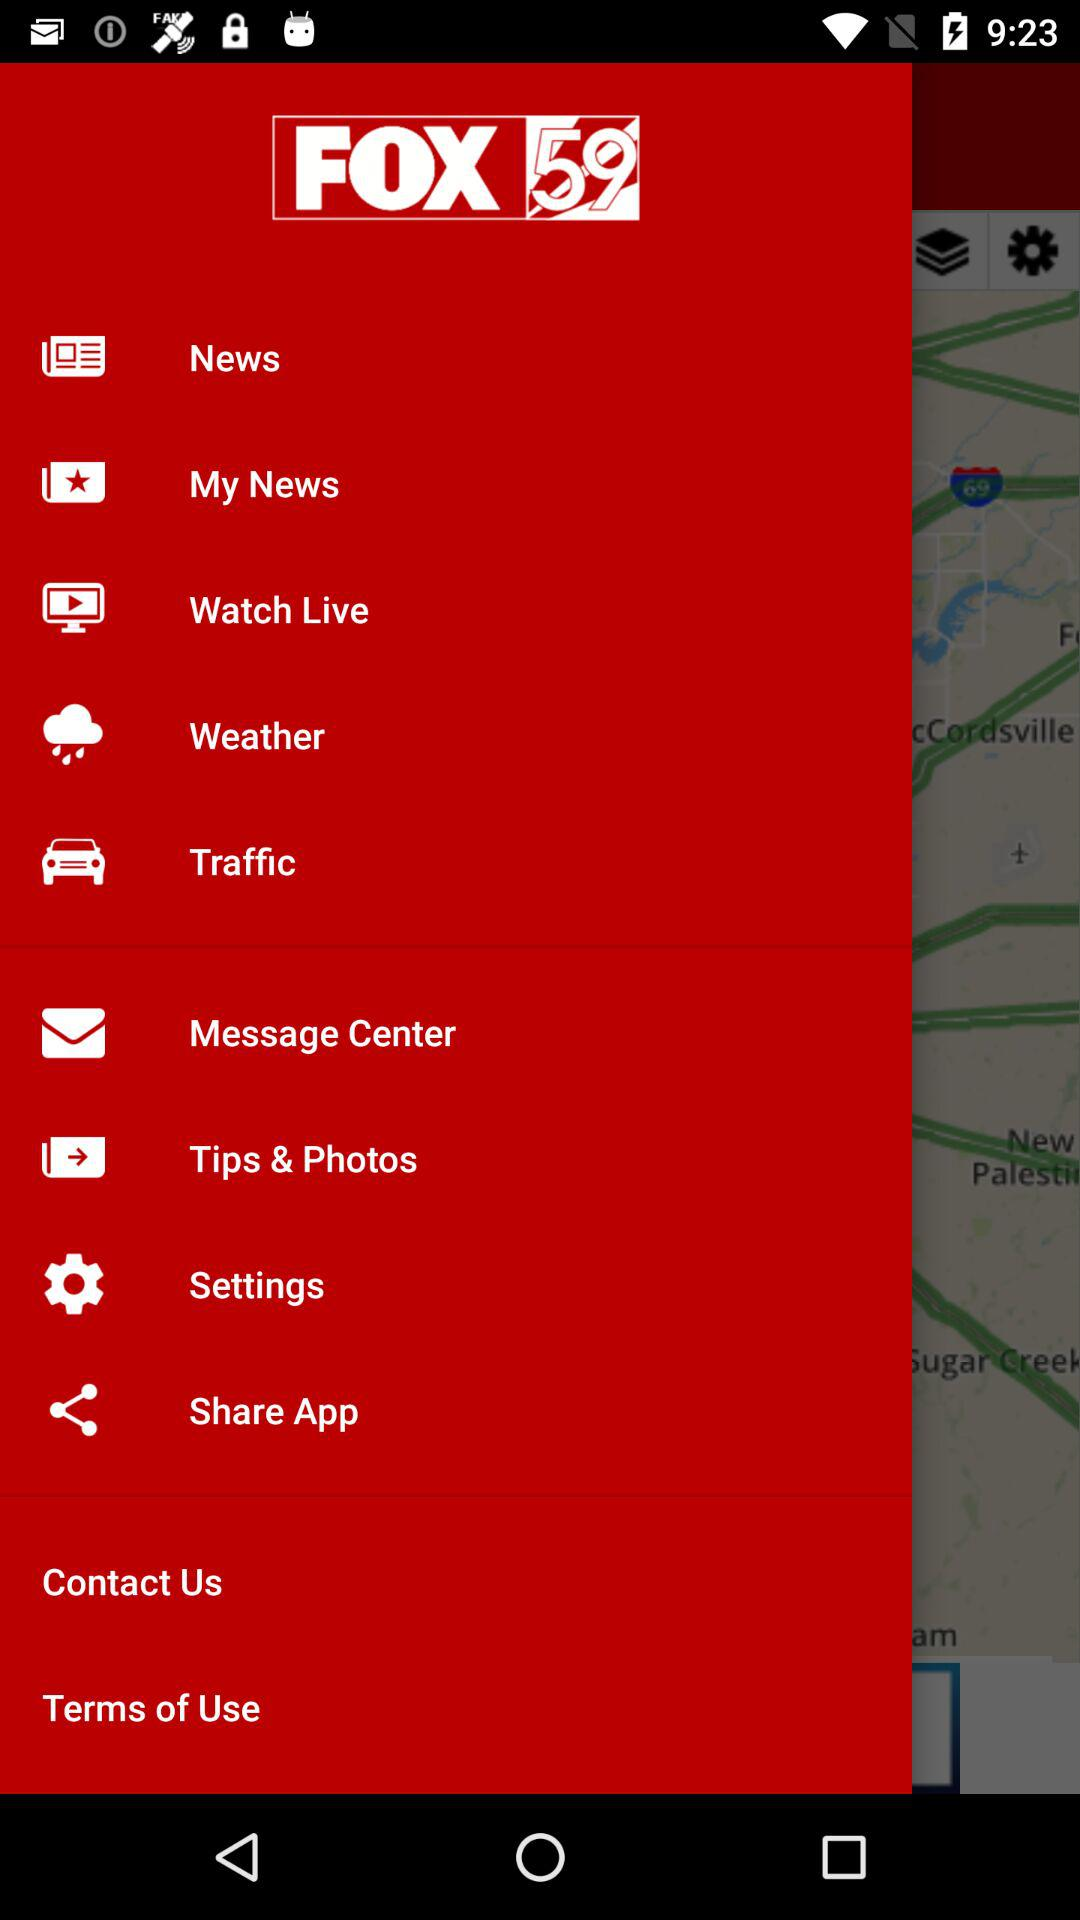What is the name of the application? The name of the application is "FOX 59". 